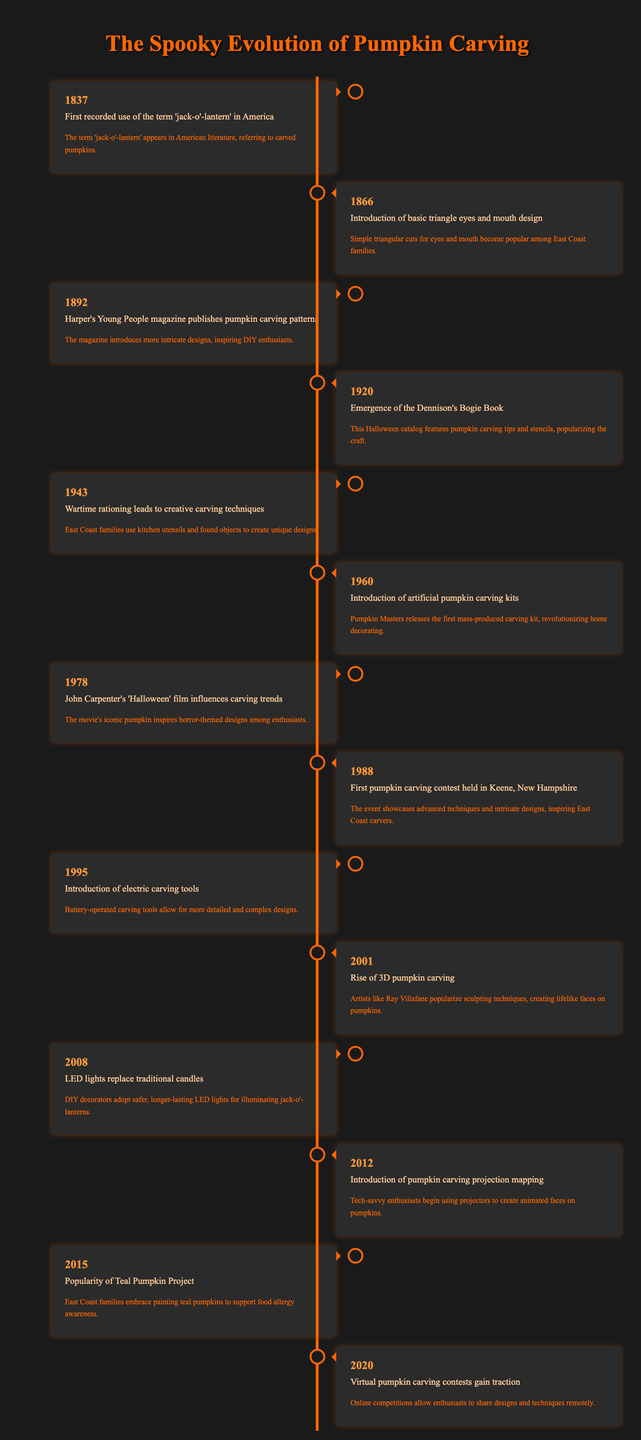What year did the term 'jack-o'-lantern' first appear in America? The timeline lists the event "First recorded use of the term 'jack-o'-lantern' in America" in the year 1837. Thus, this is the year when the term was first recorded in America.
Answer: 1837 Which design elements became popular in pumpkin carving in 1866? The timeline indicates that in 1866, the "Introduction of basic triangle eyes and mouth design" occurred, where simple triangular cuts for eyes and mouth gained popularity among families.
Answer: Basic triangle eyes and mouth design How many years passed between the introduction of electric carving tools and the rise of 3D pumpkin carving? The events "Introduction of electric carving tools" occurred in 1995 and "Rise of 3D pumpkin carving" in 2001. The difference between these years is 2001 - 1995 = 6. Therefore, 6 years passed between these two events.
Answer: 6 years Did the popularity of the Teal Pumpkin Project begin before 2015? According to the timeline, the event related to the Teal Pumpkin Project is listed under the year 2015, indicating its popularity commenced in that year. Therefore, it did not begin before 2015.
Answer: No How did wartime rationing affect pumpkin carving in 1943? The timeline states that in 1943, "Wartime rationing leads to creative carving techniques," which suggests that due to rationing, families had to rely on kitchen utensils and found objects, leading to innovative designs that were different from more traditional carving methods used prior to this period.
Answer: It encouraged creative techniques using found objects and kitchen utensils What is the significance of the year 1988 in pumpkin carving history? The timeline notes that 1988 marked the "First pumpkin carving contest held in Keene, New Hampshire." This event was important as it showcased advanced techniques and intricate designs, inspiring local carvers and enhancing the pumpkin carving community.
Answer: It introduced the first pumpkin carving contest What technological advancement in pumpkin carving occurred in 2008? According to the timeline, in 2008, "LED lights replace traditional candles," indicating that this technology allowed pumpkin carvers to use safer and longer-lasting illumination methods for their jack-o'-lanterns.
Answer: LED lights replaced traditional candles Which two events mark significant changes in pumpkin carving techniques after 2001? The event in 2001 was "Rise of 3D pumpkin carving," followed by "Introduction of pumpkin carving projection mapping" in 2012. Together, these events show the shift towards incorporating more sophisticated sculpting methods and technological innovations in pumpkin decoration.
Answer: The rise of 3D carving and introduction of projection mapping 